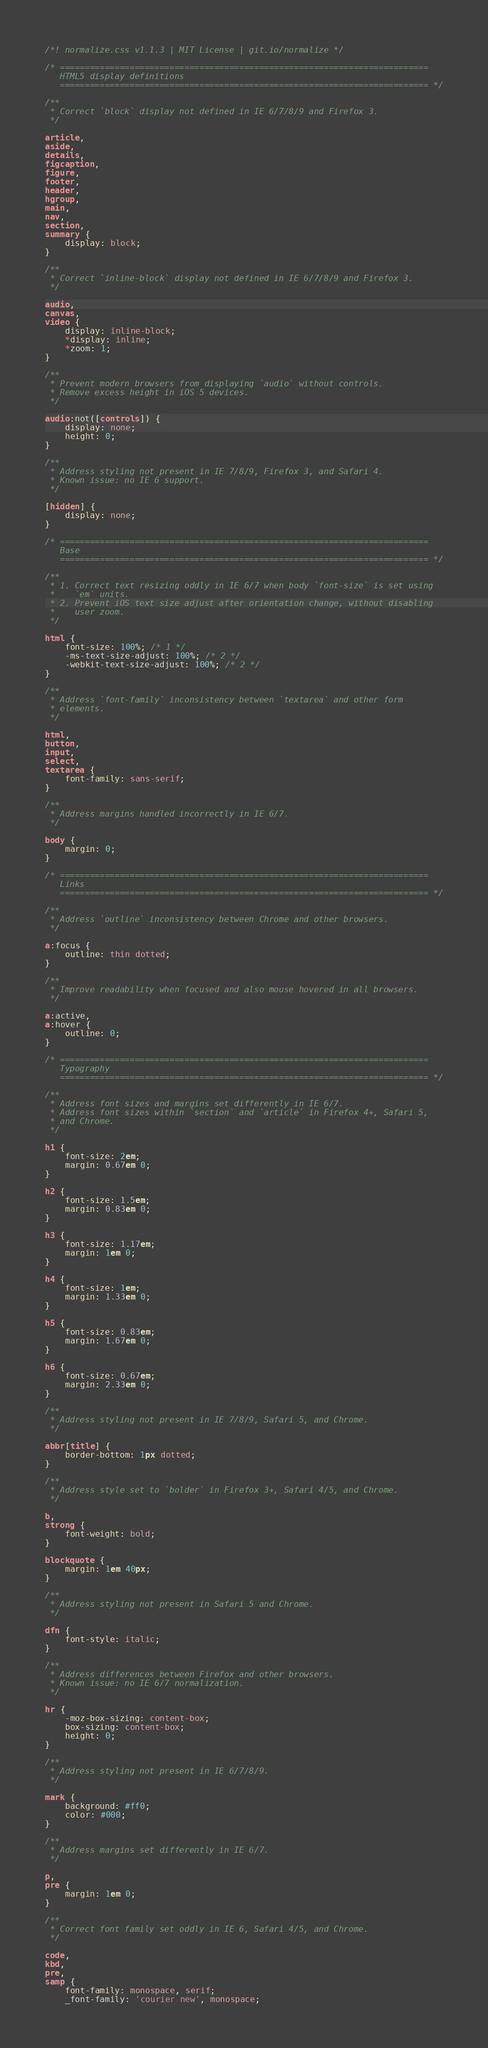<code> <loc_0><loc_0><loc_500><loc_500><_CSS_>/*! normalize.css v1.1.3 | MIT License | git.io/normalize */

/* ==========================================================================
   HTML5 display definitions
   ========================================================================== */

/**
 * Correct `block` display not defined in IE 6/7/8/9 and Firefox 3.
 */

article,
aside,
details,
figcaption,
figure,
footer,
header,
hgroup,
main,
nav,
section,
summary {
    display: block;
}

/**
 * Correct `inline-block` display not defined in IE 6/7/8/9 and Firefox 3.
 */

audio,
canvas,
video {
    display: inline-block;
    *display: inline;
    *zoom: 1;
}

/**
 * Prevent modern browsers from displaying `audio` without controls.
 * Remove excess height in iOS 5 devices.
 */

audio:not([controls]) {
    display: none;
    height: 0;
}

/**
 * Address styling not present in IE 7/8/9, Firefox 3, and Safari 4.
 * Known issue: no IE 6 support.
 */

[hidden] {
    display: none;
}

/* ==========================================================================
   Base
   ========================================================================== */

/**
 * 1. Correct text resizing oddly in IE 6/7 when body `font-size` is set using
 *    `em` units.
 * 2. Prevent iOS text size adjust after orientation change, without disabling
 *    user zoom.
 */

html {
    font-size: 100%; /* 1 */
    -ms-text-size-adjust: 100%; /* 2 */
    -webkit-text-size-adjust: 100%; /* 2 */
}

/**
 * Address `font-family` inconsistency between `textarea` and other form
 * elements.
 */

html,
button,
input,
select,
textarea {
    font-family: sans-serif;
}

/**
 * Address margins handled incorrectly in IE 6/7.
 */

body {
    margin: 0;
}

/* ==========================================================================
   Links
   ========================================================================== */

/**
 * Address `outline` inconsistency between Chrome and other browsers.
 */

a:focus {
    outline: thin dotted;
}

/**
 * Improve readability when focused and also mouse hovered in all browsers.
 */

a:active,
a:hover {
    outline: 0;
}

/* ==========================================================================
   Typography
   ========================================================================== */

/**
 * Address font sizes and margins set differently in IE 6/7.
 * Address font sizes within `section` and `article` in Firefox 4+, Safari 5,
 * and Chrome.
 */

h1 {
    font-size: 2em;
    margin: 0.67em 0;
}

h2 {
    font-size: 1.5em;
    margin: 0.83em 0;
}

h3 {
    font-size: 1.17em;
    margin: 1em 0;
}

h4 {
    font-size: 1em;
    margin: 1.33em 0;
}

h5 {
    font-size: 0.83em;
    margin: 1.67em 0;
}

h6 {
    font-size: 0.67em;
    margin: 2.33em 0;
}

/**
 * Address styling not present in IE 7/8/9, Safari 5, and Chrome.
 */

abbr[title] {
    border-bottom: 1px dotted;
}

/**
 * Address style set to `bolder` in Firefox 3+, Safari 4/5, and Chrome.
 */

b,
strong {
    font-weight: bold;
}

blockquote {
    margin: 1em 40px;
}

/**
 * Address styling not present in Safari 5 and Chrome.
 */

dfn {
    font-style: italic;
}

/**
 * Address differences between Firefox and other browsers.
 * Known issue: no IE 6/7 normalization.
 */

hr {
    -moz-box-sizing: content-box;
    box-sizing: content-box;
    height: 0;
}

/**
 * Address styling not present in IE 6/7/8/9.
 */

mark {
    background: #ff0;
    color: #000;
}

/**
 * Address margins set differently in IE 6/7.
 */

p,
pre {
    margin: 1em 0;
}

/**
 * Correct font family set oddly in IE 6, Safari 4/5, and Chrome.
 */

code,
kbd,
pre,
samp {
    font-family: monospace, serif;
    _font-family: 'courier new', monospace;</code> 